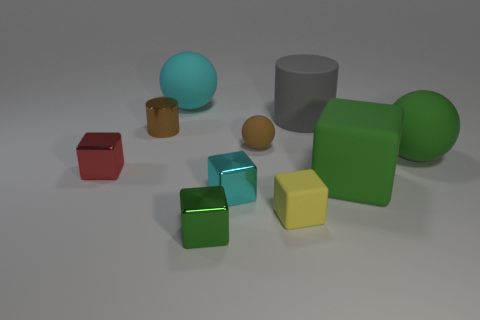Subtract all large matte spheres. How many spheres are left? 1 Subtract 1 spheres. How many spheres are left? 2 Subtract all cylinders. How many objects are left? 8 Subtract 0 purple spheres. How many objects are left? 10 Subtract all gray blocks. Subtract all gray cylinders. How many blocks are left? 5 Subtract all green cylinders. How many green cubes are left? 2 Subtract all tiny brown objects. Subtract all red blocks. How many objects are left? 7 Add 4 green rubber objects. How many green rubber objects are left? 6 Add 6 small brown matte spheres. How many small brown matte spheres exist? 7 Subtract all cyan balls. How many balls are left? 2 